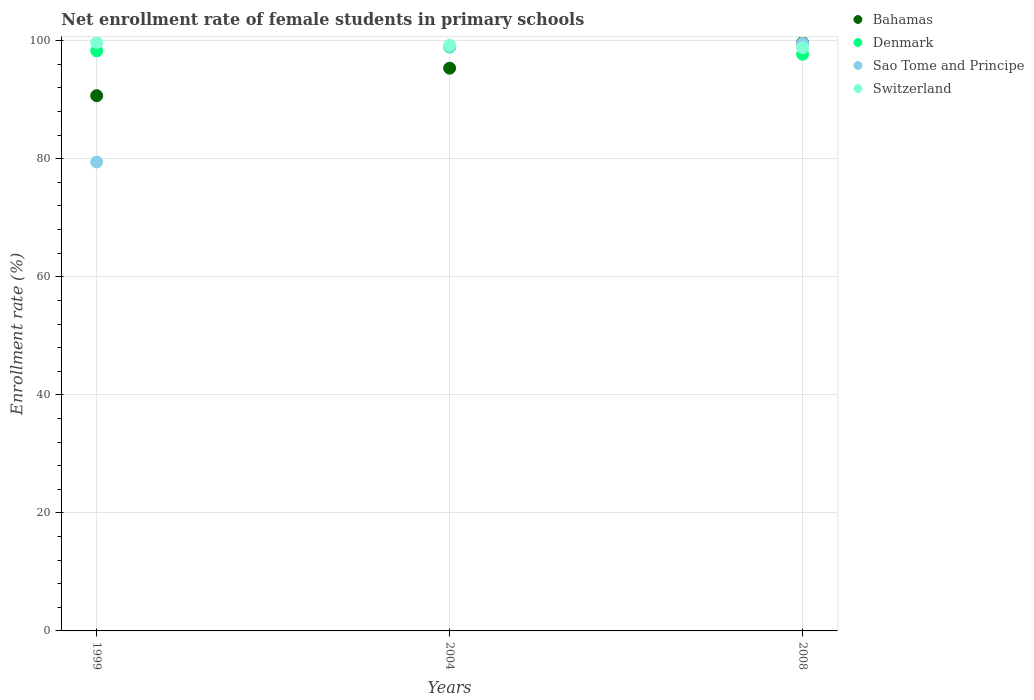How many different coloured dotlines are there?
Offer a terse response. 4. What is the net enrollment rate of female students in primary schools in Denmark in 2008?
Offer a terse response. 97.71. Across all years, what is the maximum net enrollment rate of female students in primary schools in Denmark?
Make the answer very short. 98.93. Across all years, what is the minimum net enrollment rate of female students in primary schools in Switzerland?
Offer a very short reply. 98.82. In which year was the net enrollment rate of female students in primary schools in Bahamas minimum?
Your answer should be very brief. 1999. What is the total net enrollment rate of female students in primary schools in Bahamas in the graph?
Offer a terse response. 285.73. What is the difference between the net enrollment rate of female students in primary schools in Switzerland in 2004 and that in 2008?
Your answer should be very brief. 0.43. What is the difference between the net enrollment rate of female students in primary schools in Switzerland in 2004 and the net enrollment rate of female students in primary schools in Sao Tome and Principe in 1999?
Offer a very short reply. 19.79. What is the average net enrollment rate of female students in primary schools in Sao Tome and Principe per year?
Give a very brief answer. 92.69. In the year 1999, what is the difference between the net enrollment rate of female students in primary schools in Bahamas and net enrollment rate of female students in primary schools in Switzerland?
Your response must be concise. -9. What is the ratio of the net enrollment rate of female students in primary schools in Denmark in 2004 to that in 2008?
Provide a succinct answer. 1.01. Is the difference between the net enrollment rate of female students in primary schools in Bahamas in 1999 and 2008 greater than the difference between the net enrollment rate of female students in primary schools in Switzerland in 1999 and 2008?
Make the answer very short. No. What is the difference between the highest and the second highest net enrollment rate of female students in primary schools in Switzerland?
Give a very brief answer. 0.45. What is the difference between the highest and the lowest net enrollment rate of female students in primary schools in Switzerland?
Give a very brief answer. 0.88. Is it the case that in every year, the sum of the net enrollment rate of female students in primary schools in Switzerland and net enrollment rate of female students in primary schools in Bahamas  is greater than the sum of net enrollment rate of female students in primary schools in Sao Tome and Principe and net enrollment rate of female students in primary schools in Denmark?
Provide a succinct answer. No. Is it the case that in every year, the sum of the net enrollment rate of female students in primary schools in Denmark and net enrollment rate of female students in primary schools in Bahamas  is greater than the net enrollment rate of female students in primary schools in Sao Tome and Principe?
Give a very brief answer. Yes. Is the net enrollment rate of female students in primary schools in Switzerland strictly greater than the net enrollment rate of female students in primary schools in Denmark over the years?
Your answer should be compact. Yes. Is the net enrollment rate of female students in primary schools in Bahamas strictly less than the net enrollment rate of female students in primary schools in Switzerland over the years?
Ensure brevity in your answer.  No. What is the difference between two consecutive major ticks on the Y-axis?
Ensure brevity in your answer.  20. Does the graph contain grids?
Your answer should be very brief. Yes. Where does the legend appear in the graph?
Make the answer very short. Top right. How are the legend labels stacked?
Give a very brief answer. Vertical. What is the title of the graph?
Provide a short and direct response. Net enrollment rate of female students in primary schools. What is the label or title of the X-axis?
Provide a succinct answer. Years. What is the label or title of the Y-axis?
Your answer should be very brief. Enrollment rate (%). What is the Enrollment rate (%) of Bahamas in 1999?
Keep it short and to the point. 90.69. What is the Enrollment rate (%) of Denmark in 1999?
Provide a succinct answer. 98.28. What is the Enrollment rate (%) in Sao Tome and Principe in 1999?
Your response must be concise. 79.45. What is the Enrollment rate (%) in Switzerland in 1999?
Give a very brief answer. 99.69. What is the Enrollment rate (%) of Bahamas in 2004?
Ensure brevity in your answer.  95.35. What is the Enrollment rate (%) in Denmark in 2004?
Give a very brief answer. 98.93. What is the Enrollment rate (%) of Sao Tome and Principe in 2004?
Make the answer very short. 99.03. What is the Enrollment rate (%) in Switzerland in 2004?
Your response must be concise. 99.25. What is the Enrollment rate (%) in Bahamas in 2008?
Keep it short and to the point. 99.69. What is the Enrollment rate (%) of Denmark in 2008?
Give a very brief answer. 97.71. What is the Enrollment rate (%) in Sao Tome and Principe in 2008?
Offer a very short reply. 99.58. What is the Enrollment rate (%) of Switzerland in 2008?
Your answer should be compact. 98.82. Across all years, what is the maximum Enrollment rate (%) of Bahamas?
Offer a very short reply. 99.69. Across all years, what is the maximum Enrollment rate (%) of Denmark?
Ensure brevity in your answer.  98.93. Across all years, what is the maximum Enrollment rate (%) in Sao Tome and Principe?
Ensure brevity in your answer.  99.58. Across all years, what is the maximum Enrollment rate (%) in Switzerland?
Your answer should be very brief. 99.69. Across all years, what is the minimum Enrollment rate (%) in Bahamas?
Provide a succinct answer. 90.69. Across all years, what is the minimum Enrollment rate (%) of Denmark?
Offer a very short reply. 97.71. Across all years, what is the minimum Enrollment rate (%) in Sao Tome and Principe?
Ensure brevity in your answer.  79.45. Across all years, what is the minimum Enrollment rate (%) of Switzerland?
Provide a short and direct response. 98.82. What is the total Enrollment rate (%) of Bahamas in the graph?
Give a very brief answer. 285.73. What is the total Enrollment rate (%) of Denmark in the graph?
Offer a very short reply. 294.92. What is the total Enrollment rate (%) of Sao Tome and Principe in the graph?
Your response must be concise. 278.06. What is the total Enrollment rate (%) in Switzerland in the graph?
Make the answer very short. 297.76. What is the difference between the Enrollment rate (%) in Bahamas in 1999 and that in 2004?
Give a very brief answer. -4.66. What is the difference between the Enrollment rate (%) of Denmark in 1999 and that in 2004?
Give a very brief answer. -0.65. What is the difference between the Enrollment rate (%) in Sao Tome and Principe in 1999 and that in 2004?
Give a very brief answer. -19.57. What is the difference between the Enrollment rate (%) of Switzerland in 1999 and that in 2004?
Offer a very short reply. 0.45. What is the difference between the Enrollment rate (%) of Bahamas in 1999 and that in 2008?
Offer a terse response. -9. What is the difference between the Enrollment rate (%) of Denmark in 1999 and that in 2008?
Your answer should be very brief. 0.58. What is the difference between the Enrollment rate (%) in Sao Tome and Principe in 1999 and that in 2008?
Make the answer very short. -20.12. What is the difference between the Enrollment rate (%) of Switzerland in 1999 and that in 2008?
Your answer should be compact. 0.88. What is the difference between the Enrollment rate (%) in Bahamas in 2004 and that in 2008?
Offer a terse response. -4.34. What is the difference between the Enrollment rate (%) in Denmark in 2004 and that in 2008?
Offer a very short reply. 1.22. What is the difference between the Enrollment rate (%) of Sao Tome and Principe in 2004 and that in 2008?
Offer a terse response. -0.55. What is the difference between the Enrollment rate (%) in Switzerland in 2004 and that in 2008?
Make the answer very short. 0.43. What is the difference between the Enrollment rate (%) of Bahamas in 1999 and the Enrollment rate (%) of Denmark in 2004?
Make the answer very short. -8.24. What is the difference between the Enrollment rate (%) in Bahamas in 1999 and the Enrollment rate (%) in Sao Tome and Principe in 2004?
Make the answer very short. -8.34. What is the difference between the Enrollment rate (%) in Bahamas in 1999 and the Enrollment rate (%) in Switzerland in 2004?
Ensure brevity in your answer.  -8.56. What is the difference between the Enrollment rate (%) of Denmark in 1999 and the Enrollment rate (%) of Sao Tome and Principe in 2004?
Ensure brevity in your answer.  -0.75. What is the difference between the Enrollment rate (%) in Denmark in 1999 and the Enrollment rate (%) in Switzerland in 2004?
Your answer should be very brief. -0.96. What is the difference between the Enrollment rate (%) of Sao Tome and Principe in 1999 and the Enrollment rate (%) of Switzerland in 2004?
Give a very brief answer. -19.79. What is the difference between the Enrollment rate (%) in Bahamas in 1999 and the Enrollment rate (%) in Denmark in 2008?
Keep it short and to the point. -7.01. What is the difference between the Enrollment rate (%) of Bahamas in 1999 and the Enrollment rate (%) of Sao Tome and Principe in 2008?
Your answer should be compact. -8.89. What is the difference between the Enrollment rate (%) in Bahamas in 1999 and the Enrollment rate (%) in Switzerland in 2008?
Your response must be concise. -8.13. What is the difference between the Enrollment rate (%) of Denmark in 1999 and the Enrollment rate (%) of Sao Tome and Principe in 2008?
Give a very brief answer. -1.29. What is the difference between the Enrollment rate (%) of Denmark in 1999 and the Enrollment rate (%) of Switzerland in 2008?
Make the answer very short. -0.53. What is the difference between the Enrollment rate (%) in Sao Tome and Principe in 1999 and the Enrollment rate (%) in Switzerland in 2008?
Provide a short and direct response. -19.36. What is the difference between the Enrollment rate (%) of Bahamas in 2004 and the Enrollment rate (%) of Denmark in 2008?
Your answer should be very brief. -2.36. What is the difference between the Enrollment rate (%) of Bahamas in 2004 and the Enrollment rate (%) of Sao Tome and Principe in 2008?
Your answer should be compact. -4.23. What is the difference between the Enrollment rate (%) in Bahamas in 2004 and the Enrollment rate (%) in Switzerland in 2008?
Offer a very short reply. -3.47. What is the difference between the Enrollment rate (%) in Denmark in 2004 and the Enrollment rate (%) in Sao Tome and Principe in 2008?
Your answer should be compact. -0.65. What is the difference between the Enrollment rate (%) in Denmark in 2004 and the Enrollment rate (%) in Switzerland in 2008?
Your response must be concise. 0.11. What is the difference between the Enrollment rate (%) of Sao Tome and Principe in 2004 and the Enrollment rate (%) of Switzerland in 2008?
Provide a succinct answer. 0.21. What is the average Enrollment rate (%) of Bahamas per year?
Your response must be concise. 95.24. What is the average Enrollment rate (%) of Denmark per year?
Your response must be concise. 98.31. What is the average Enrollment rate (%) in Sao Tome and Principe per year?
Keep it short and to the point. 92.69. What is the average Enrollment rate (%) in Switzerland per year?
Ensure brevity in your answer.  99.25. In the year 1999, what is the difference between the Enrollment rate (%) of Bahamas and Enrollment rate (%) of Denmark?
Offer a terse response. -7.59. In the year 1999, what is the difference between the Enrollment rate (%) of Bahamas and Enrollment rate (%) of Sao Tome and Principe?
Your response must be concise. 11.24. In the year 1999, what is the difference between the Enrollment rate (%) in Bahamas and Enrollment rate (%) in Switzerland?
Give a very brief answer. -9. In the year 1999, what is the difference between the Enrollment rate (%) of Denmark and Enrollment rate (%) of Sao Tome and Principe?
Provide a succinct answer. 18.83. In the year 1999, what is the difference between the Enrollment rate (%) of Denmark and Enrollment rate (%) of Switzerland?
Keep it short and to the point. -1.41. In the year 1999, what is the difference between the Enrollment rate (%) in Sao Tome and Principe and Enrollment rate (%) in Switzerland?
Keep it short and to the point. -20.24. In the year 2004, what is the difference between the Enrollment rate (%) in Bahamas and Enrollment rate (%) in Denmark?
Ensure brevity in your answer.  -3.58. In the year 2004, what is the difference between the Enrollment rate (%) in Bahamas and Enrollment rate (%) in Sao Tome and Principe?
Make the answer very short. -3.68. In the year 2004, what is the difference between the Enrollment rate (%) of Bahamas and Enrollment rate (%) of Switzerland?
Keep it short and to the point. -3.9. In the year 2004, what is the difference between the Enrollment rate (%) in Denmark and Enrollment rate (%) in Sao Tome and Principe?
Give a very brief answer. -0.1. In the year 2004, what is the difference between the Enrollment rate (%) of Denmark and Enrollment rate (%) of Switzerland?
Give a very brief answer. -0.32. In the year 2004, what is the difference between the Enrollment rate (%) of Sao Tome and Principe and Enrollment rate (%) of Switzerland?
Make the answer very short. -0.22. In the year 2008, what is the difference between the Enrollment rate (%) in Bahamas and Enrollment rate (%) in Denmark?
Provide a succinct answer. 1.99. In the year 2008, what is the difference between the Enrollment rate (%) in Bahamas and Enrollment rate (%) in Sao Tome and Principe?
Your answer should be compact. 0.12. In the year 2008, what is the difference between the Enrollment rate (%) of Bahamas and Enrollment rate (%) of Switzerland?
Your response must be concise. 0.88. In the year 2008, what is the difference between the Enrollment rate (%) of Denmark and Enrollment rate (%) of Sao Tome and Principe?
Offer a very short reply. -1.87. In the year 2008, what is the difference between the Enrollment rate (%) in Denmark and Enrollment rate (%) in Switzerland?
Give a very brief answer. -1.11. In the year 2008, what is the difference between the Enrollment rate (%) in Sao Tome and Principe and Enrollment rate (%) in Switzerland?
Provide a short and direct response. 0.76. What is the ratio of the Enrollment rate (%) of Bahamas in 1999 to that in 2004?
Make the answer very short. 0.95. What is the ratio of the Enrollment rate (%) of Sao Tome and Principe in 1999 to that in 2004?
Ensure brevity in your answer.  0.8. What is the ratio of the Enrollment rate (%) of Switzerland in 1999 to that in 2004?
Give a very brief answer. 1. What is the ratio of the Enrollment rate (%) in Bahamas in 1999 to that in 2008?
Provide a short and direct response. 0.91. What is the ratio of the Enrollment rate (%) of Denmark in 1999 to that in 2008?
Your answer should be compact. 1.01. What is the ratio of the Enrollment rate (%) of Sao Tome and Principe in 1999 to that in 2008?
Your response must be concise. 0.8. What is the ratio of the Enrollment rate (%) of Switzerland in 1999 to that in 2008?
Your response must be concise. 1.01. What is the ratio of the Enrollment rate (%) of Bahamas in 2004 to that in 2008?
Ensure brevity in your answer.  0.96. What is the ratio of the Enrollment rate (%) in Denmark in 2004 to that in 2008?
Your answer should be compact. 1.01. What is the ratio of the Enrollment rate (%) in Switzerland in 2004 to that in 2008?
Make the answer very short. 1. What is the difference between the highest and the second highest Enrollment rate (%) in Bahamas?
Offer a very short reply. 4.34. What is the difference between the highest and the second highest Enrollment rate (%) of Denmark?
Make the answer very short. 0.65. What is the difference between the highest and the second highest Enrollment rate (%) in Sao Tome and Principe?
Your answer should be very brief. 0.55. What is the difference between the highest and the second highest Enrollment rate (%) in Switzerland?
Ensure brevity in your answer.  0.45. What is the difference between the highest and the lowest Enrollment rate (%) in Bahamas?
Provide a succinct answer. 9. What is the difference between the highest and the lowest Enrollment rate (%) in Denmark?
Provide a succinct answer. 1.22. What is the difference between the highest and the lowest Enrollment rate (%) of Sao Tome and Principe?
Keep it short and to the point. 20.12. What is the difference between the highest and the lowest Enrollment rate (%) of Switzerland?
Provide a succinct answer. 0.88. 